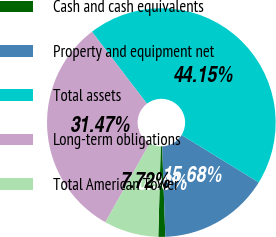Convert chart. <chart><loc_0><loc_0><loc_500><loc_500><pie_chart><fcel>Cash and cash equivalents<fcel>Property and equipment net<fcel>Total assets<fcel>Long-term obligations<fcel>Total American Tower<nl><fcel>0.98%<fcel>15.68%<fcel>44.15%<fcel>31.47%<fcel>7.72%<nl></chart> 